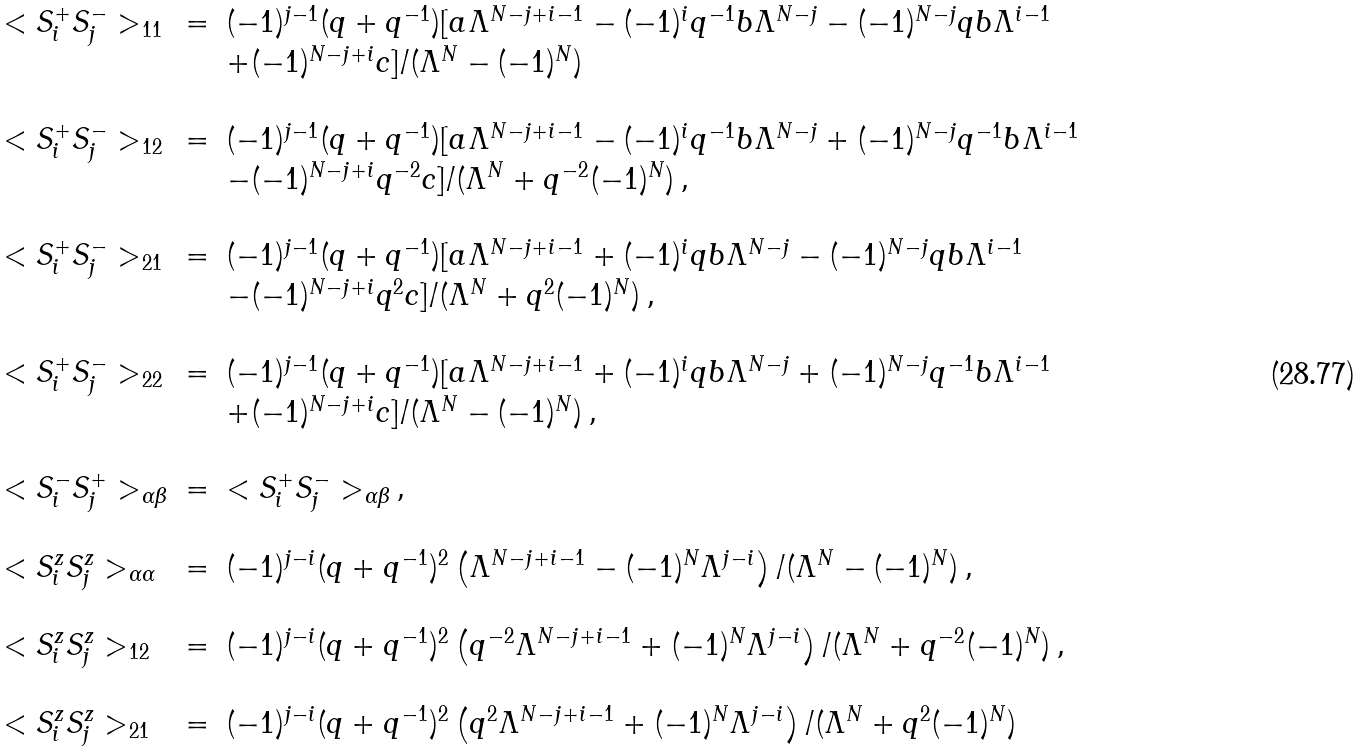<formula> <loc_0><loc_0><loc_500><loc_500>\begin{array} { l l l } < S _ { i } ^ { + } S _ { j } ^ { - } > _ { 1 1 } & = & ( - 1 ) ^ { j - 1 } ( q + q ^ { - 1 } ) [ a \Lambda ^ { N - j + i - 1 } - ( - 1 ) ^ { i } q ^ { - 1 } b \Lambda ^ { N - j } - ( - 1 ) ^ { N - j } q b \Lambda ^ { i - 1 } \\ & & + ( - 1 ) ^ { N - j + i } c ] / ( \Lambda ^ { N } - ( - 1 ) ^ { N } ) \\ \\ < S _ { i } ^ { + } S _ { j } ^ { - } > _ { 1 2 } & = & ( - 1 ) ^ { j - 1 } ( q + q ^ { - 1 } ) [ a \Lambda ^ { N - j + i - 1 } - ( - 1 ) ^ { i } q ^ { - 1 } b \Lambda ^ { N - j } + ( - 1 ) ^ { N - j } q ^ { - 1 } b \Lambda ^ { i - 1 } \\ & & - ( - 1 ) ^ { N - j + i } q ^ { - 2 } c ] / ( \Lambda ^ { N } + q ^ { - 2 } ( - 1 ) ^ { N } ) \, , \\ \\ < S _ { i } ^ { + } S _ { j } ^ { - } > _ { 2 1 } & = & ( - 1 ) ^ { j - 1 } ( q + q ^ { - 1 } ) [ a \Lambda ^ { N - j + i - 1 } + ( - 1 ) ^ { i } q b \Lambda ^ { N - j } - ( - 1 ) ^ { N - j } q b \Lambda ^ { i - 1 } \\ & & - ( - 1 ) ^ { N - j + i } q ^ { 2 } c ] / ( \Lambda ^ { N } + q ^ { 2 } ( - 1 ) ^ { N } ) \, , \\ \\ < S _ { i } ^ { + } S _ { j } ^ { - } > _ { 2 2 } & = & ( - 1 ) ^ { j - 1 } ( q + q ^ { - 1 } ) [ a \Lambda ^ { N - j + i - 1 } + ( - 1 ) ^ { i } q b \Lambda ^ { N - j } + ( - 1 ) ^ { N - j } q ^ { - 1 } b \Lambda ^ { i - 1 } \\ & & + ( - 1 ) ^ { N - j + i } c ] / ( \Lambda ^ { N } - ( - 1 ) ^ { N } ) \, , \\ \\ < S _ { i } ^ { - } S _ { j } ^ { + } > _ { \alpha \beta } & = & < S _ { i } ^ { + } S _ { j } ^ { - } > _ { \alpha \beta } \, , \\ \\ < S _ { i } ^ { z } S ^ { z } _ { j } > _ { \alpha \alpha } & = & ( - 1 ) ^ { j - i } ( q + q ^ { - 1 } ) ^ { 2 } \left ( \Lambda ^ { N - j + i - 1 } - ( - 1 ) ^ { N } \Lambda ^ { j - i } \right ) / ( \Lambda ^ { N } - ( - 1 ) ^ { N } ) \, , \\ \\ < S _ { i } ^ { z } S ^ { z } _ { j } > _ { 1 2 } & = & ( - 1 ) ^ { j - i } ( q + q ^ { - 1 } ) ^ { 2 } \left ( q ^ { - 2 } \Lambda ^ { N - j + i - 1 } + ( - 1 ) ^ { N } \Lambda ^ { j - i } \right ) / ( \Lambda ^ { N } + q ^ { - 2 } ( - 1 ) ^ { N } ) \, , \\ \\ < S _ { i } ^ { z } S ^ { z } _ { j } > _ { 2 1 } & = & ( - 1 ) ^ { j - i } ( q + q ^ { - 1 } ) ^ { 2 } \left ( q ^ { 2 } \Lambda ^ { N - j + i - 1 } + ( - 1 ) ^ { N } \Lambda ^ { j - i } \right ) / ( \Lambda ^ { N } + q ^ { 2 } ( - 1 ) ^ { N } ) \end{array}</formula> 